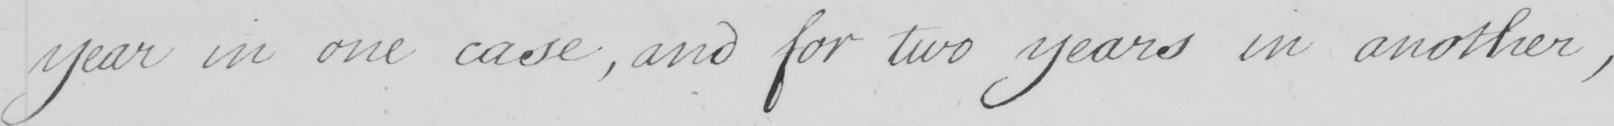Please transcribe the handwritten text in this image. year in one case , and for two years in another , 